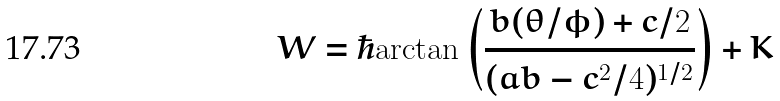<formula> <loc_0><loc_0><loc_500><loc_500>W = \hbar { \arctan } \left ( \frac { b ( \theta / \phi ) + c / 2 } { ( a b - c ^ { 2 } / 4 ) ^ { 1 / 2 } } \right ) + K</formula> 